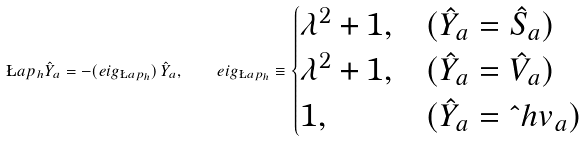Convert formula to latex. <formula><loc_0><loc_0><loc_500><loc_500>\L a p _ { h } \hat { Y } _ { a } = - ( e i g _ { \L a p _ { h } } ) \, \hat { Y } _ { a } , \quad e i g _ { \L a p _ { h } } \equiv \begin{cases} \lambda ^ { 2 } + 1 , & ( \hat { Y } _ { a } = \hat { S } _ { a } ) \\ \lambda ^ { 2 } + 1 , & ( \hat { Y } _ { a } = \hat { V } _ { a } ) \\ 1 , & ( \hat { Y } _ { a } = \hat { \ } h v _ { a } ) \end{cases}</formula> 